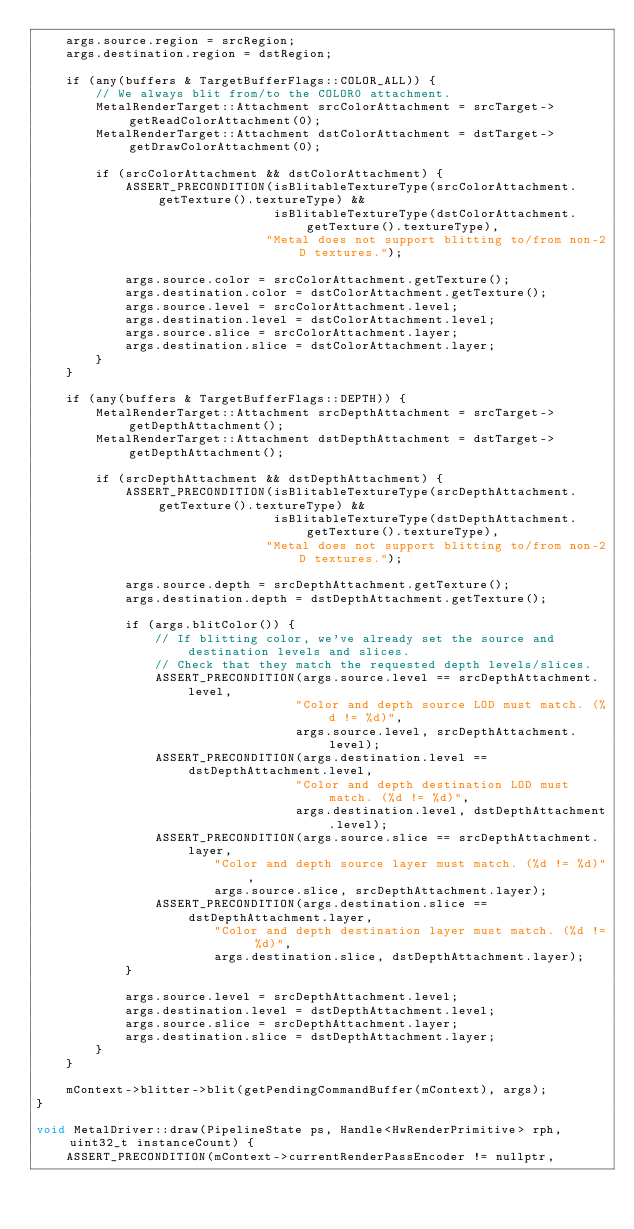<code> <loc_0><loc_0><loc_500><loc_500><_ObjectiveC_>    args.source.region = srcRegion;
    args.destination.region = dstRegion;

    if (any(buffers & TargetBufferFlags::COLOR_ALL)) {
        // We always blit from/to the COLOR0 attachment.
        MetalRenderTarget::Attachment srcColorAttachment = srcTarget->getReadColorAttachment(0);
        MetalRenderTarget::Attachment dstColorAttachment = dstTarget->getDrawColorAttachment(0);

        if (srcColorAttachment && dstColorAttachment) {
            ASSERT_PRECONDITION(isBlitableTextureType(srcColorAttachment.getTexture().textureType) &&
                                isBlitableTextureType(dstColorAttachment.getTexture().textureType),
                               "Metal does not support blitting to/from non-2D textures.");

            args.source.color = srcColorAttachment.getTexture();
            args.destination.color = dstColorAttachment.getTexture();
            args.source.level = srcColorAttachment.level;
            args.destination.level = dstColorAttachment.level;
            args.source.slice = srcColorAttachment.layer;
            args.destination.slice = dstColorAttachment.layer;
        }
    }

    if (any(buffers & TargetBufferFlags::DEPTH)) {
        MetalRenderTarget::Attachment srcDepthAttachment = srcTarget->getDepthAttachment();
        MetalRenderTarget::Attachment dstDepthAttachment = dstTarget->getDepthAttachment();

        if (srcDepthAttachment && dstDepthAttachment) {
            ASSERT_PRECONDITION(isBlitableTextureType(srcDepthAttachment.getTexture().textureType) &&
                                isBlitableTextureType(dstDepthAttachment.getTexture().textureType),
                               "Metal does not support blitting to/from non-2D textures.");

            args.source.depth = srcDepthAttachment.getTexture();
            args.destination.depth = dstDepthAttachment.getTexture();

            if (args.blitColor()) {
                // If blitting color, we've already set the source and destination levels and slices.
                // Check that they match the requested depth levels/slices.
                ASSERT_PRECONDITION(args.source.level == srcDepthAttachment.level,
                                   "Color and depth source LOD must match. (%d != %d)",
                                   args.source.level, srcDepthAttachment.level);
                ASSERT_PRECONDITION(args.destination.level == dstDepthAttachment.level,
                                   "Color and depth destination LOD must match. (%d != %d)",
                                   args.destination.level, dstDepthAttachment.level);
                ASSERT_PRECONDITION(args.source.slice == srcDepthAttachment.layer,
                        "Color and depth source layer must match. (%d != %d)",
                        args.source.slice, srcDepthAttachment.layer);
                ASSERT_PRECONDITION(args.destination.slice == dstDepthAttachment.layer,
                        "Color and depth destination layer must match. (%d != %d)",
                        args.destination.slice, dstDepthAttachment.layer);
            }

            args.source.level = srcDepthAttachment.level;
            args.destination.level = dstDepthAttachment.level;
            args.source.slice = srcDepthAttachment.layer;
            args.destination.slice = dstDepthAttachment.layer;
        }
    }

    mContext->blitter->blit(getPendingCommandBuffer(mContext), args);
}

void MetalDriver::draw(PipelineState ps, Handle<HwRenderPrimitive> rph, uint32_t instanceCount) {
    ASSERT_PRECONDITION(mContext->currentRenderPassEncoder != nullptr,</code> 